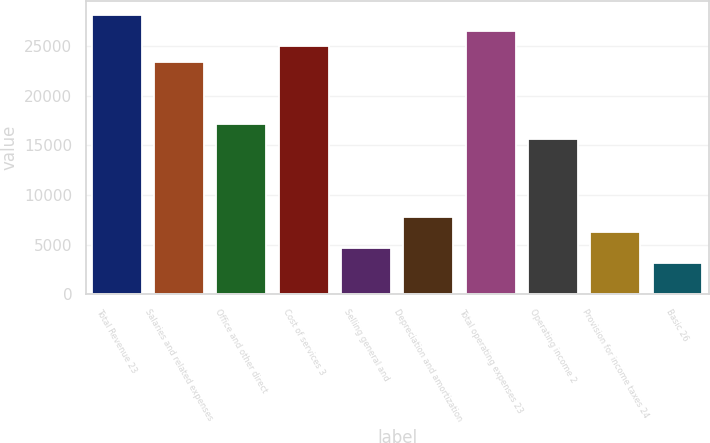Convert chart to OTSL. <chart><loc_0><loc_0><loc_500><loc_500><bar_chart><fcel>Total Revenue 23<fcel>Salaries and related expenses<fcel>Office and other direct<fcel>Cost of services 3<fcel>Selling general and<fcel>Depreciation and amortization<fcel>Total operating expenses 23<fcel>Operating income 2<fcel>Provision for income taxes 24<fcel>Basic 26<nl><fcel>28115.9<fcel>23430.1<fcel>17182.3<fcel>24992<fcel>4686.69<fcel>7810.59<fcel>26554<fcel>15620.3<fcel>6248.64<fcel>3124.74<nl></chart> 